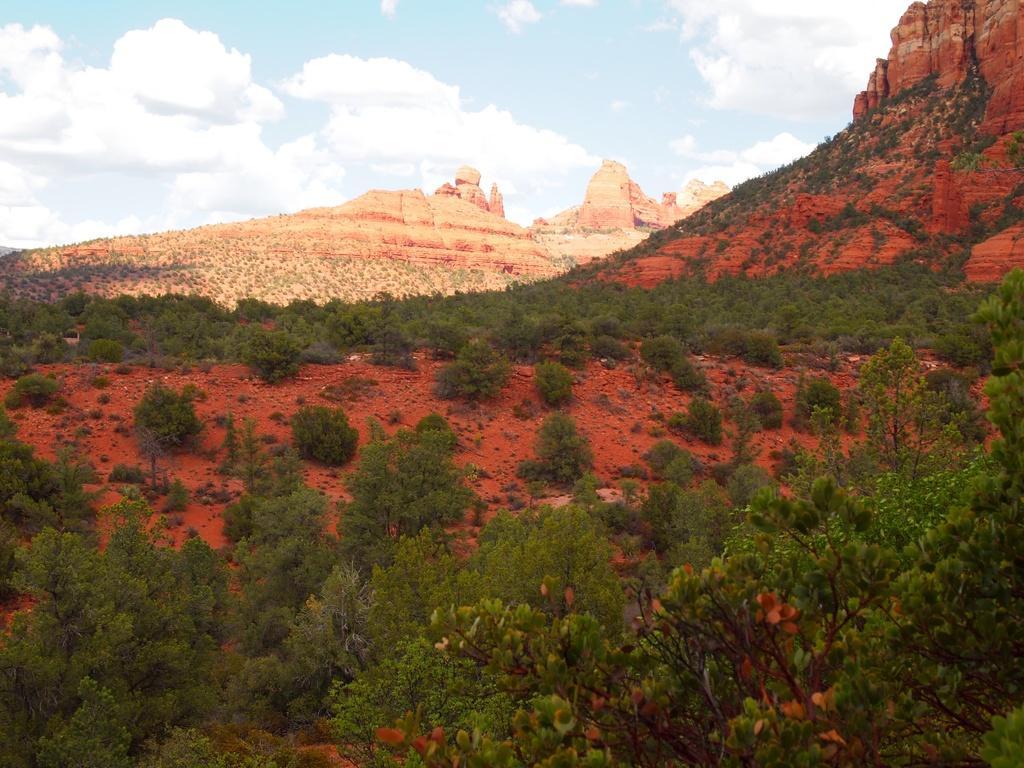Describe this image in one or two sentences. In this image we can see plants, trees, ground, and rocks. In the background there is sky with clouds. 